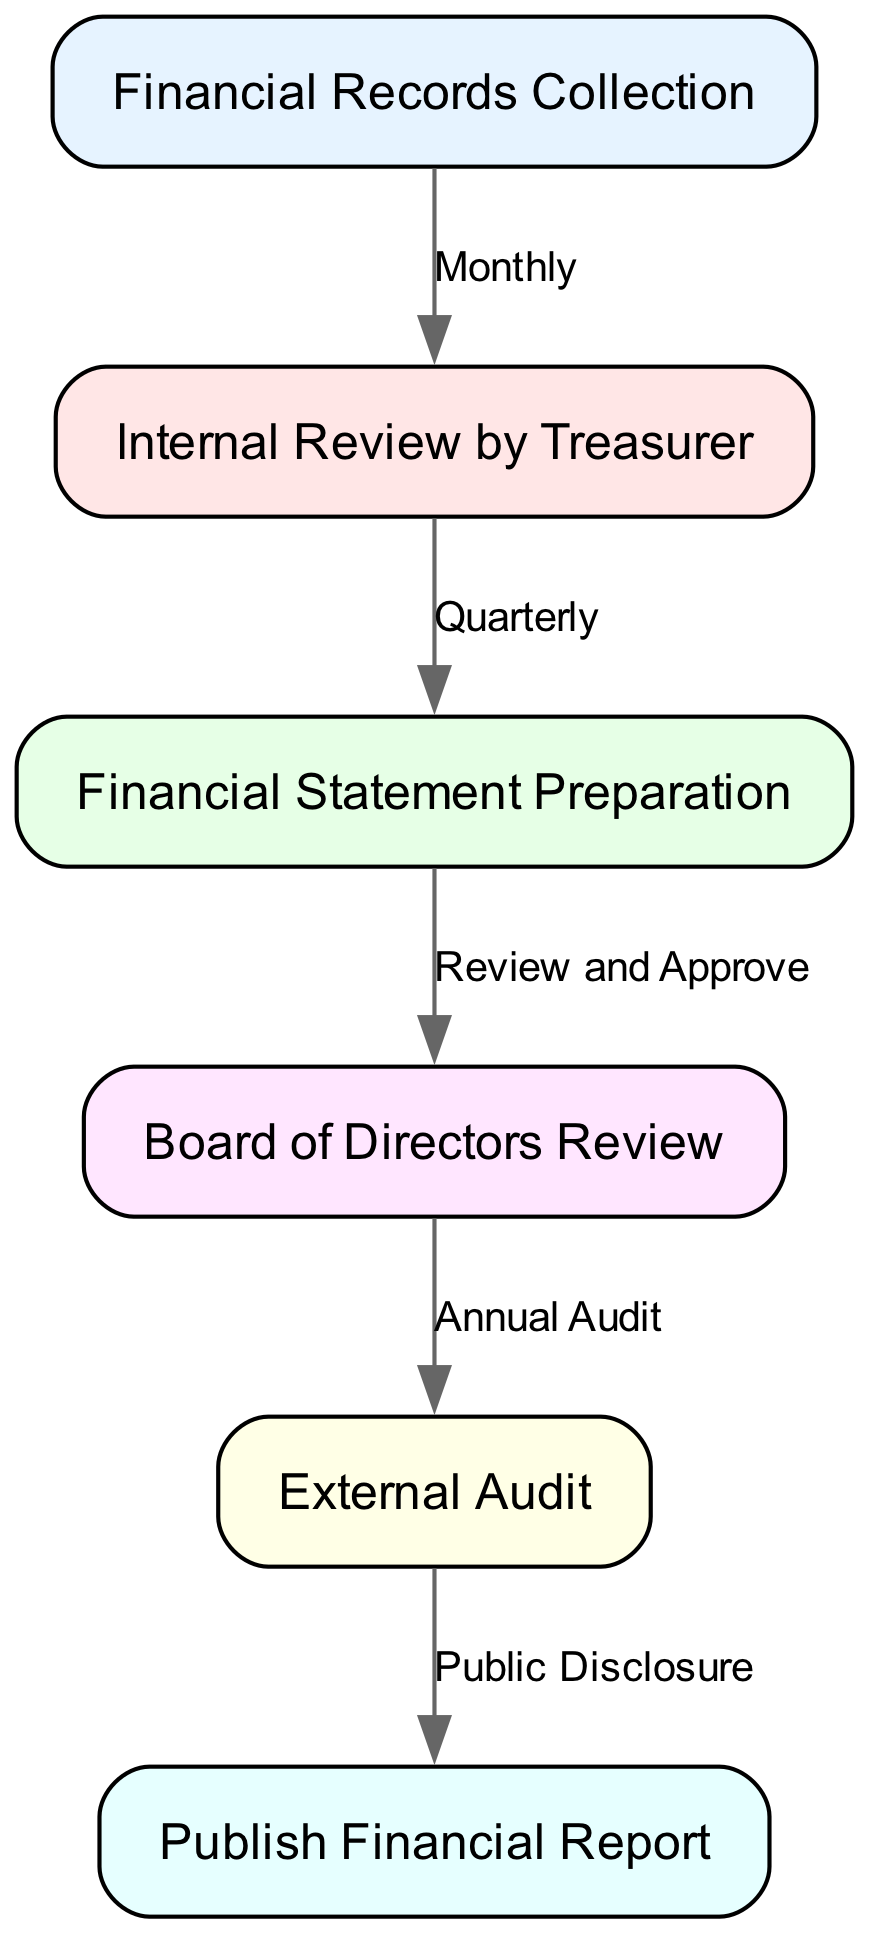What is the first step in the financial reporting process? The first step in the financial reporting process is "Financial Records Collection," which is the initial node in the diagram.
Answer: Financial Records Collection How many nodes are present in the diagram? The diagram contains a total of six nodes, which represent distinct steps in the financial reporting process.
Answer: 6 What is the frequency of the internal review conducted by the treasurer? According to the diagram, the internal review by the treasurer occurs on a "Quarterly" basis, as indicated by the label on the edge connecting the respective nodes.
Answer: Quarterly Which node follows the “Board of Directors Review”? Following the "Board of Directors Review," the next node is "External Audit," as shown by the directional flow in the diagram.
Answer: External Audit What label is associated with the edge connecting "External Audit" to "Publish Financial Report"? The label on the edge connecting "External Audit" to "Publish Financial Report" is "Public Disclosure," indicating the process that follows the external audit before publishing the financial report.
Answer: Public Disclosure What is the relationship between "Financial Statement Preparation" and "Board of Directors Review"? The relationship is characterized by the label "Review and Approve," which indicates that the Board of Directors is responsible for reviewing and approving the financial statements prepared.
Answer: Review and Approve Which responsible party is indicated for the internal review step? The responsible party indicated for the internal review step is the "Treasurer," who conducts this review as part of the financial reporting process.
Answer: Treasurer What comes after "Financial Records Collection" in terms of process flow? After "Financial Records Collection," the next step in the process flow is "Internal Review by Treasurer," marking the progression to the next stage.
Answer: Internal Review by Treasurer 